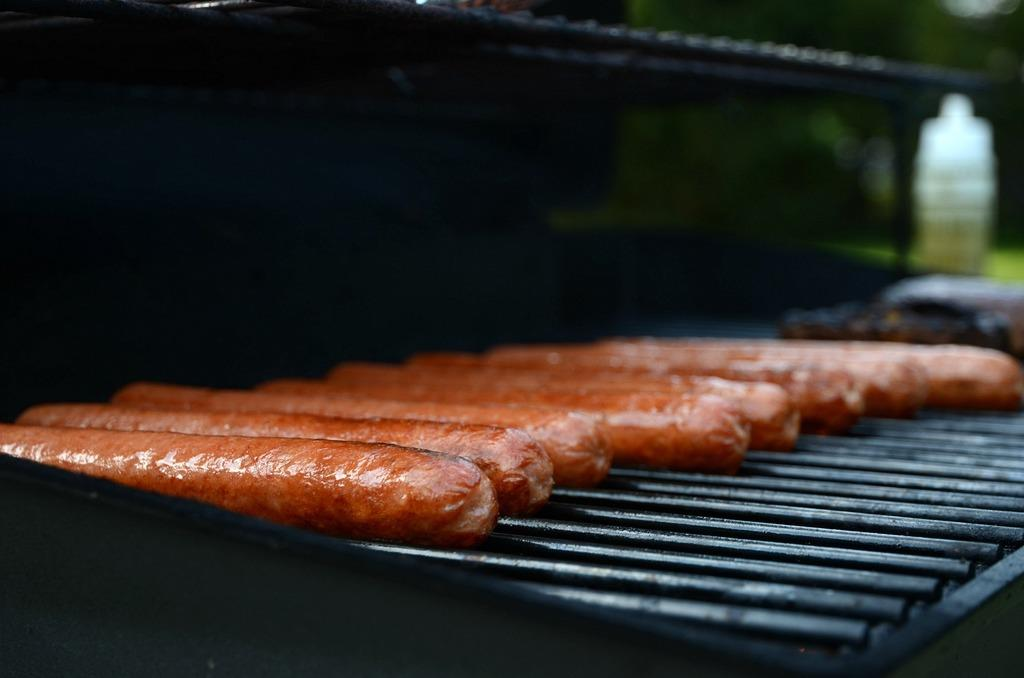What type of food can be seen on the grills in the image? There are sausages on black grills in the image. What is the color of the grills? The grills are black. Can you describe the background of the image? The background of the image appears to be black and is blurred. What type of wine is being served with the sausages in the image? There is no wine present in the image; it only features sausages on black grills. How does the beginner chef feel about grilling sausages in the image? There is no information about a chef, let alone their skill level or feelings, in the image. 